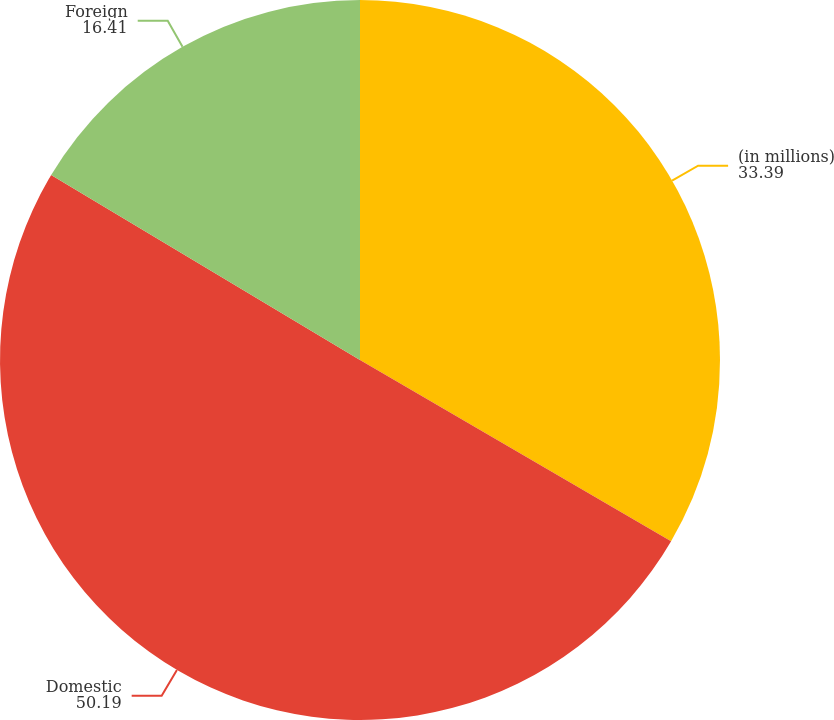<chart> <loc_0><loc_0><loc_500><loc_500><pie_chart><fcel>(in millions)<fcel>Domestic<fcel>Foreign<nl><fcel>33.39%<fcel>50.19%<fcel>16.41%<nl></chart> 